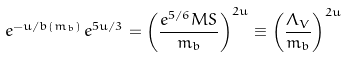<formula> <loc_0><loc_0><loc_500><loc_500>e ^ { - u / b ( m _ { b } ) } \, e ^ { 5 u / 3 } = \left ( \frac { e ^ { 5 / 6 } \L M S } { m _ { b } } \right ) ^ { 2 u } \equiv \left ( \frac { \Lambda _ { V } } { m _ { b } } \right ) ^ { 2 u }</formula> 